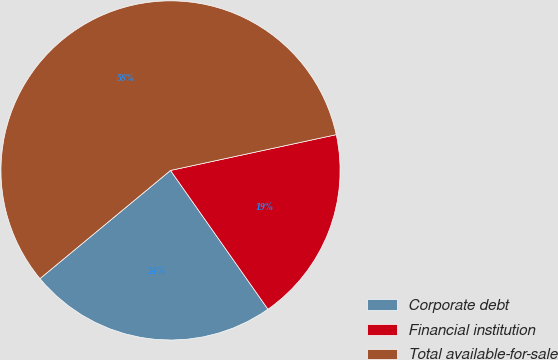Convert chart to OTSL. <chart><loc_0><loc_0><loc_500><loc_500><pie_chart><fcel>Corporate debt<fcel>Financial institution<fcel>Total available-for-sale<nl><fcel>23.73%<fcel>18.64%<fcel>57.63%<nl></chart> 